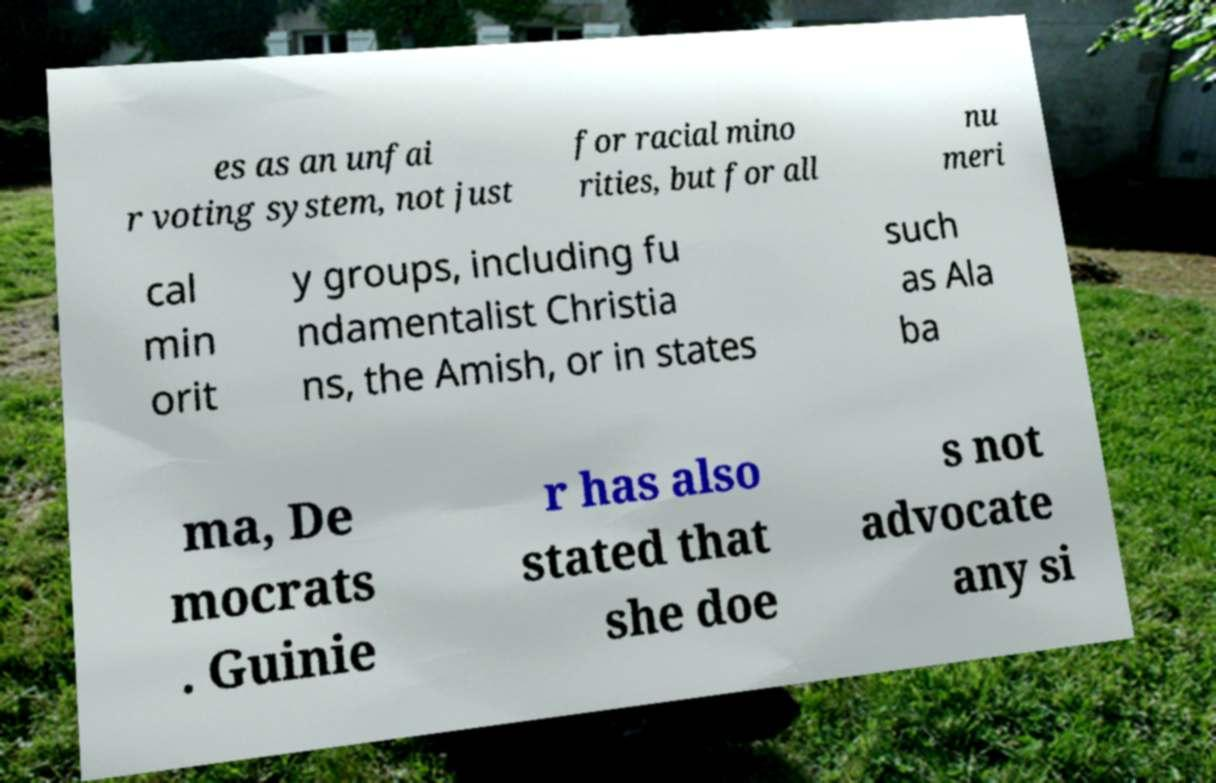Can you read and provide the text displayed in the image?This photo seems to have some interesting text. Can you extract and type it out for me? es as an unfai r voting system, not just for racial mino rities, but for all nu meri cal min orit y groups, including fu ndamentalist Christia ns, the Amish, or in states such as Ala ba ma, De mocrats . Guinie r has also stated that she doe s not advocate any si 